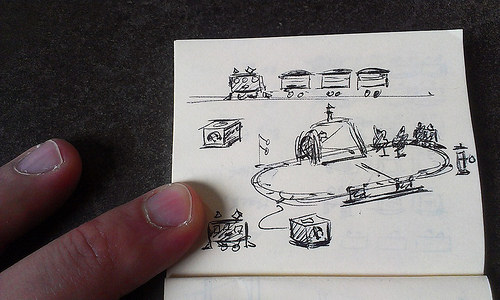<image>
Can you confirm if the paper is on the table? Yes. Looking at the image, I can see the paper is positioned on top of the table, with the table providing support. Is there a train on the tracks? No. The train is not positioned on the tracks. They may be near each other, but the train is not supported by or resting on top of the tracks. 